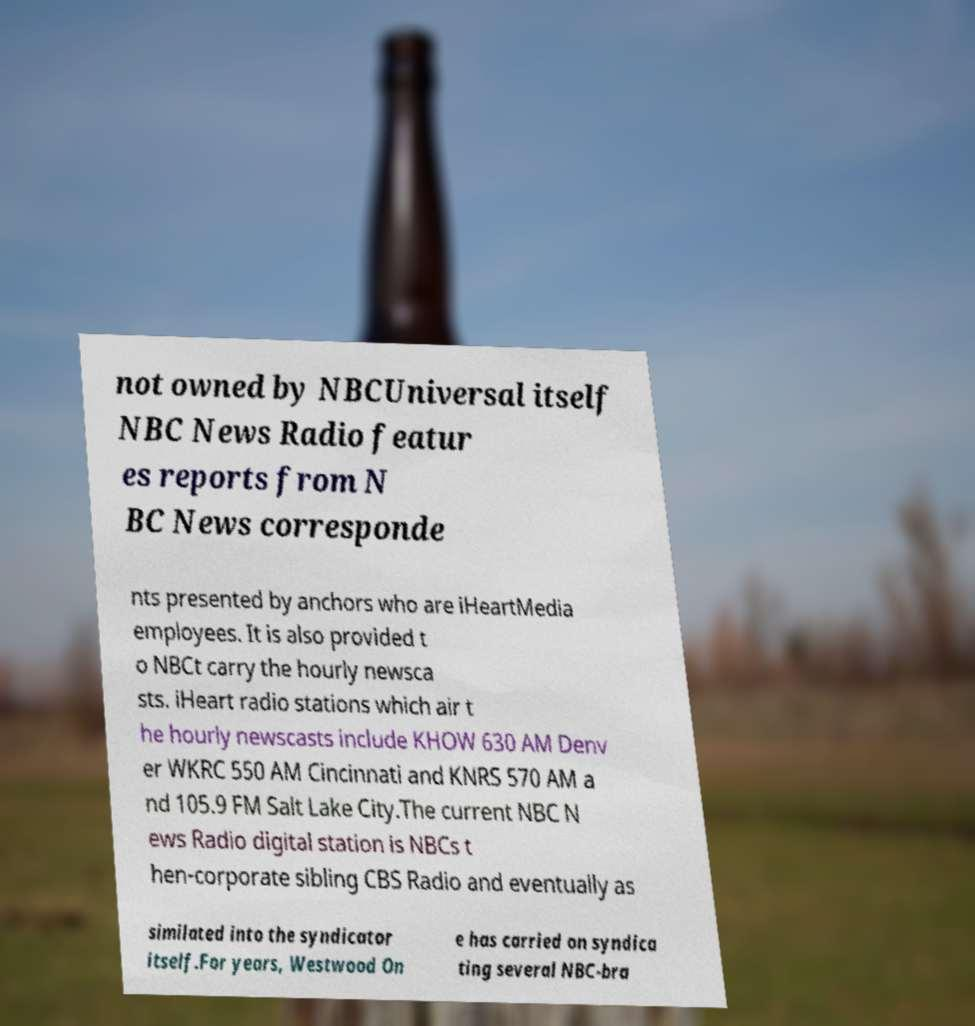What messages or text are displayed in this image? I need them in a readable, typed format. not owned by NBCUniversal itself NBC News Radio featur es reports from N BC News corresponde nts presented by anchors who are iHeartMedia employees. It is also provided t o NBCt carry the hourly newsca sts. iHeart radio stations which air t he hourly newscasts include KHOW 630 AM Denv er WKRC 550 AM Cincinnati and KNRS 570 AM a nd 105.9 FM Salt Lake City.The current NBC N ews Radio digital station is NBCs t hen-corporate sibling CBS Radio and eventually as similated into the syndicator itself.For years, Westwood On e has carried on syndica ting several NBC-bra 